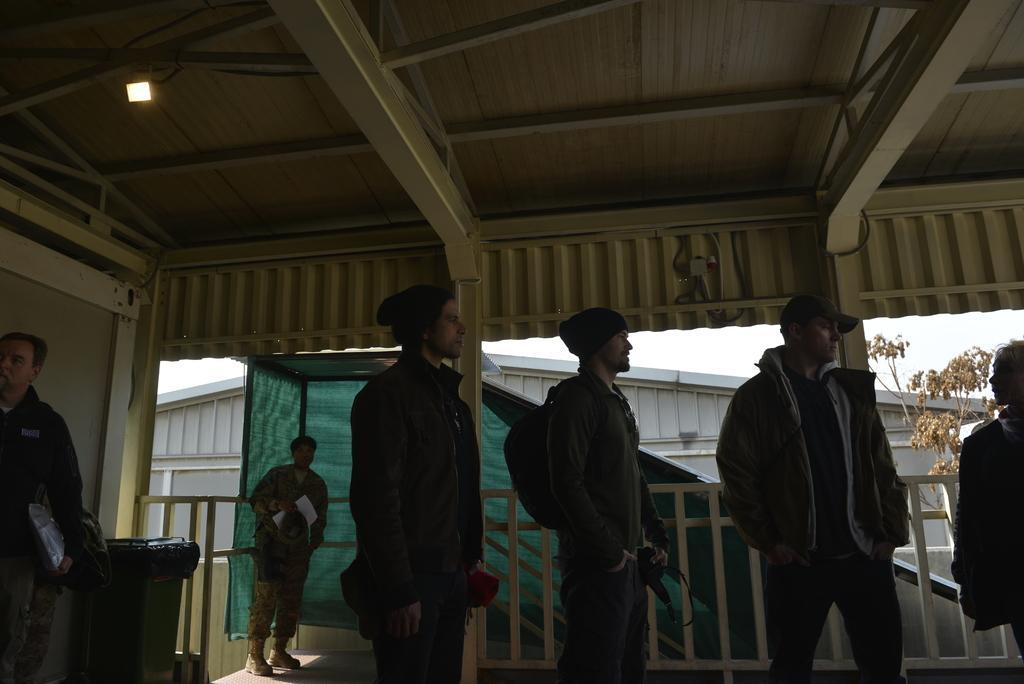Could you give a brief overview of what you see in this image? In this image we can see men standing on the floor. In the background we can see cloth, shed, bins and sky. 